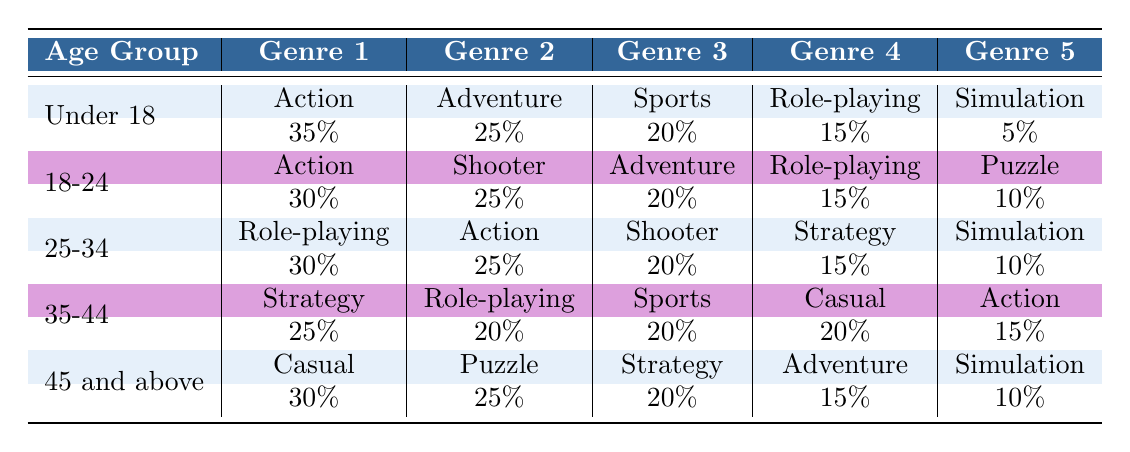What is the most popular game genre for people under 18? According to the table, the most popular game genre for the age group "Under 18" is "Action," which has a percentage of 35%.
Answer: Action What genre is the second most popular among users aged 18-24? For the age group "18-24," the second most popular genre is "Adventure," which accounts for 20% of preferences, following "Shooter" at 25%.
Answer: Adventure What percentage of the "35-44" age group prefers Casual games? In the "35-44" age group, "Casual" games are preferred by 20% of players. This is represented clearly in the table under the respective age group.
Answer: 20% Are Action games more popular than Sports games for those aged 25-34? Yes, Action games are more popular than Sports games in the "25-34" age group. Action has 25% compared to Sports, which has 20%.
Answer: Yes What is the total percentage of game genre preferences for the "45 and above" age group? To find the total for the "45 and above" age group, we sum the percentage values: 30 + 25 + 20 + 15 + 10 = 100%. Therefore, the total percentage is 100%.
Answer: 100% Which age group has the highest percentage for Role-playing games? The "25-34" age group has the highest percentage for Role-playing games at 30%. In this case, the table demonstrates that it indeed stands out in that age group compared to others.
Answer: 25-34 What is the difference in popularity between Adventure games for those aged under 18 and those aged 18-24? To determine the difference, we subtract the percentage of Adventure games in both age groups: 25% (18-24) - 20% (Under 18) = 5%. Hence, Adventure games are 5% more popular among the 18-24 age group.
Answer: 5% Is Puzzle the least popular genre for the "45 and above" group? No, Puzzle is not the least popular genre for the "45 and above" group. "Simulation" has the least preference at 10%, while Puzzle has 25%.
Answer: No In which age group is Strategy the most popular genre? The most popular age group for Strategy is "35-44," where it accounts for 25%. The table indicates that while it has significant presence in this group, it is not the leading percentile, unlike Role-playing.
Answer: 35-44 